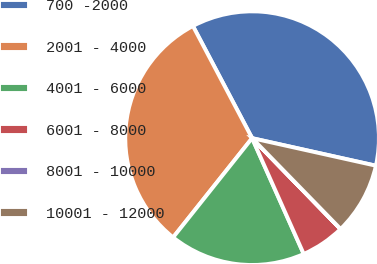Convert chart. <chart><loc_0><loc_0><loc_500><loc_500><pie_chart><fcel>700 -2000<fcel>2001 - 4000<fcel>4001 - 6000<fcel>6001 - 8000<fcel>8001 - 10000<fcel>10001 - 12000<nl><fcel>36.2%<fcel>31.57%<fcel>17.37%<fcel>5.6%<fcel>0.02%<fcel>9.22%<nl></chart> 